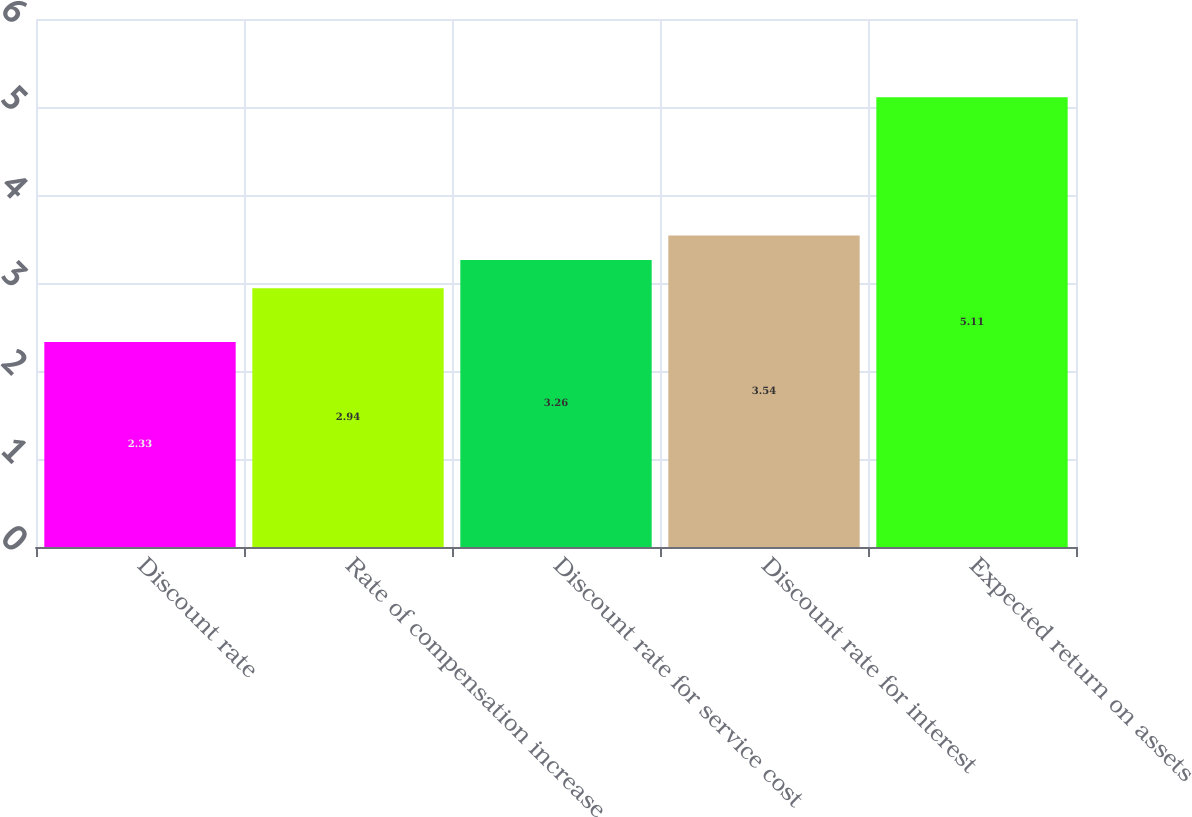Convert chart to OTSL. <chart><loc_0><loc_0><loc_500><loc_500><bar_chart><fcel>Discount rate<fcel>Rate of compensation increase<fcel>Discount rate for service cost<fcel>Discount rate for interest<fcel>Expected return on assets<nl><fcel>2.33<fcel>2.94<fcel>3.26<fcel>3.54<fcel>5.11<nl></chart> 